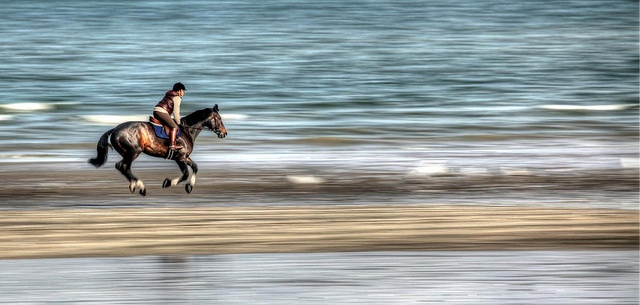Describe the objects in this image and their specific colors. I can see horse in gray, black, and maroon tones and people in gray, black, maroon, brown, and tan tones in this image. 